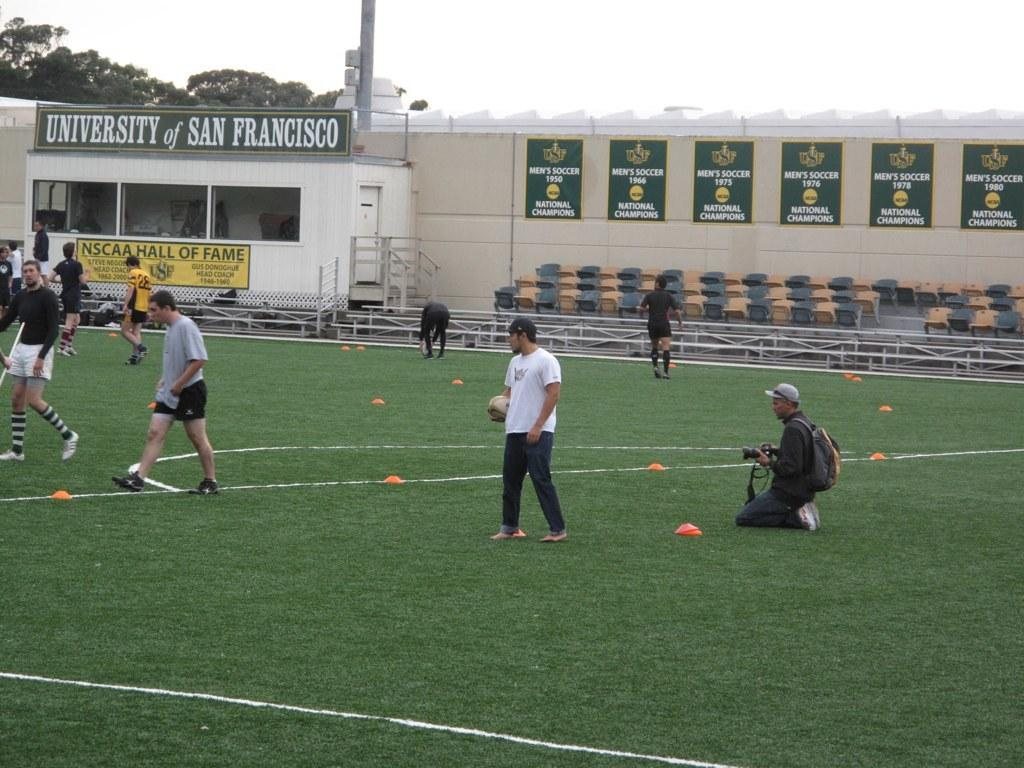<image>
Create a compact narrative representing the image presented. The school in the picture is the University of San Francisco 